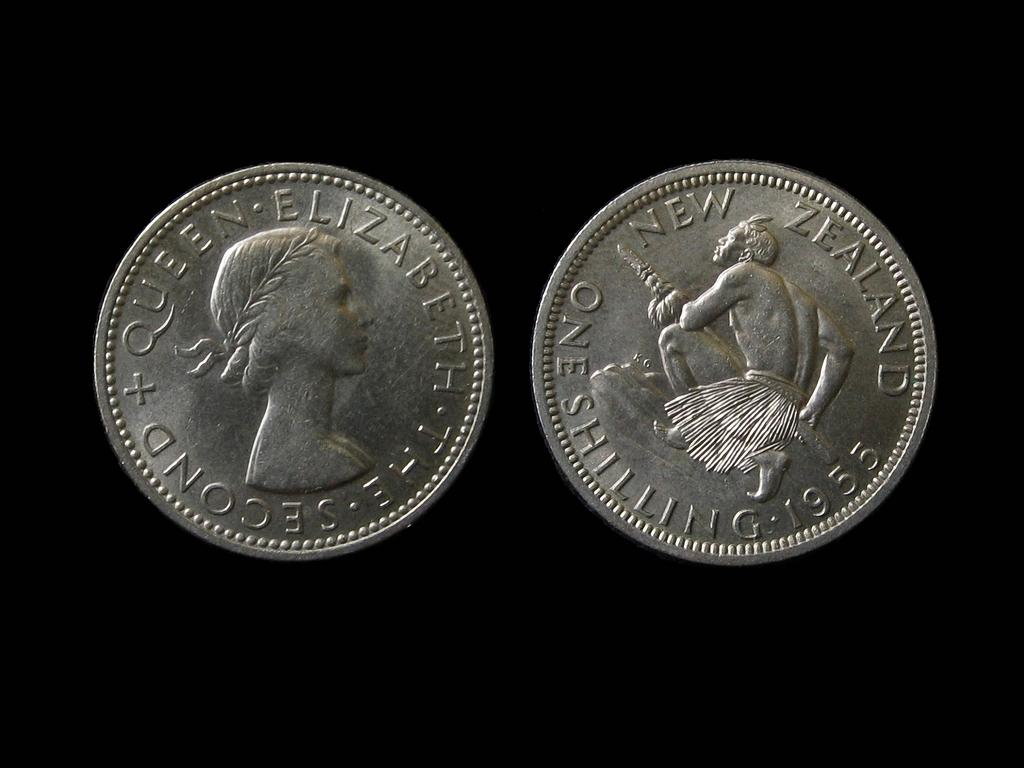<image>
Present a compact description of the photo's key features. Two coins, one with Queen Elizabeth and the other a New Zealand shilling, are set against a black background. 